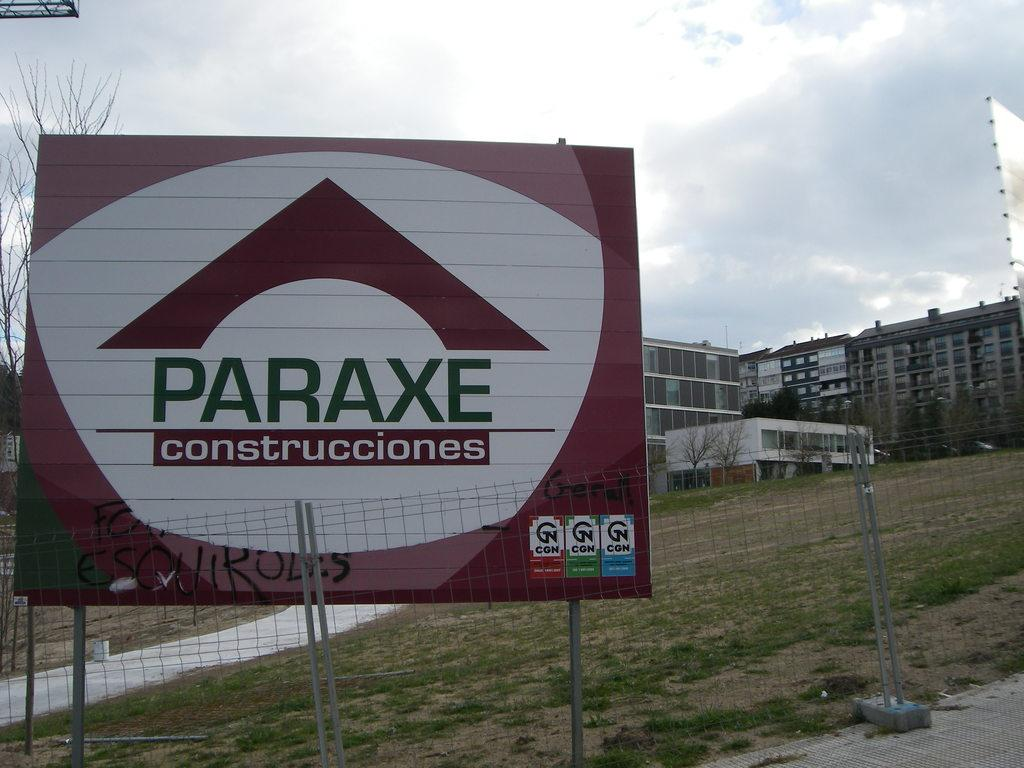Provide a one-sentence caption for the provided image. a Paraxe sogn having to do with construcciones. 